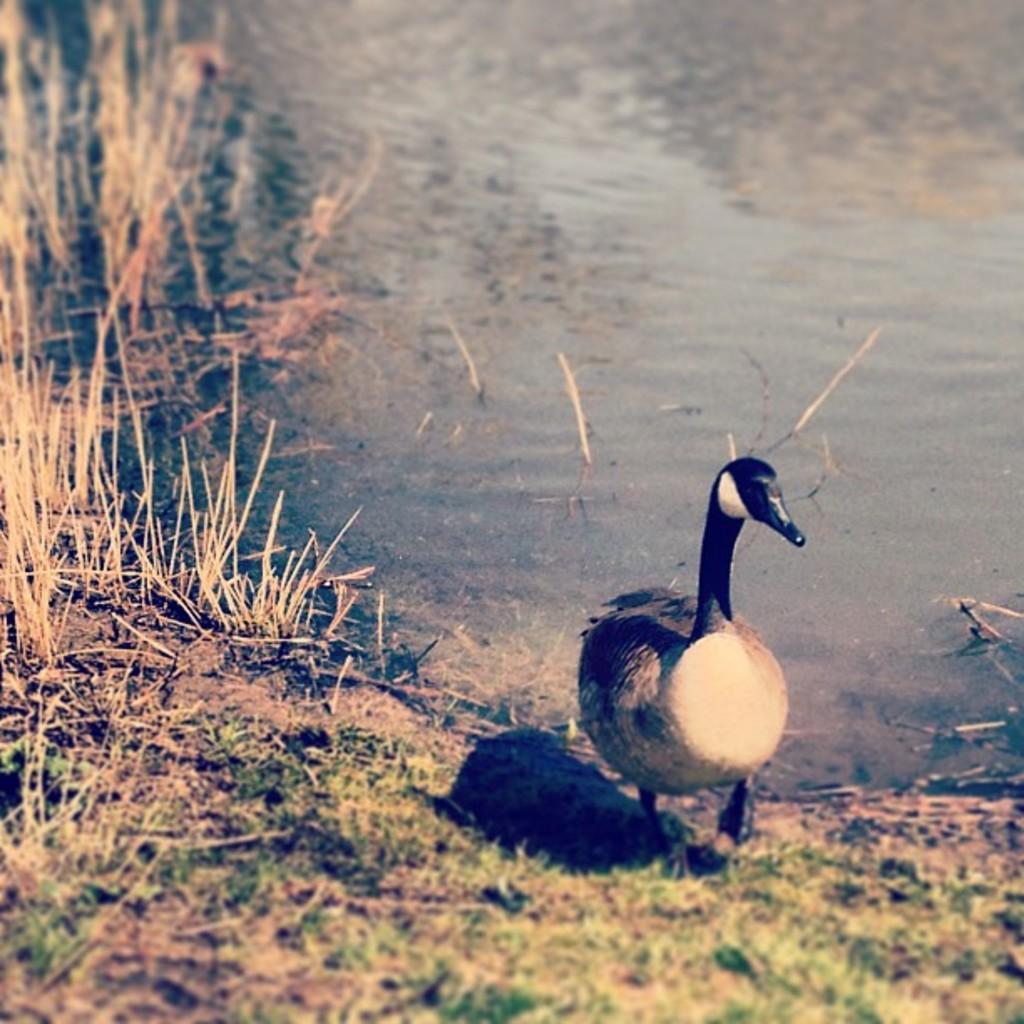Could you give a brief overview of what you see in this image? In this image I can see a bird is walking on the land. Beside it I can see the water. On the left side I can the grass. 